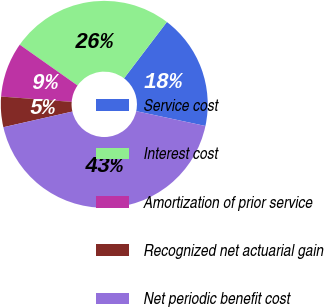Convert chart. <chart><loc_0><loc_0><loc_500><loc_500><pie_chart><fcel>Service cost<fcel>Interest cost<fcel>Amortization of prior service<fcel>Recognized net actuarial gain<fcel>Net periodic benefit cost<nl><fcel>18.01%<fcel>25.57%<fcel>8.58%<fcel>4.75%<fcel>43.1%<nl></chart> 